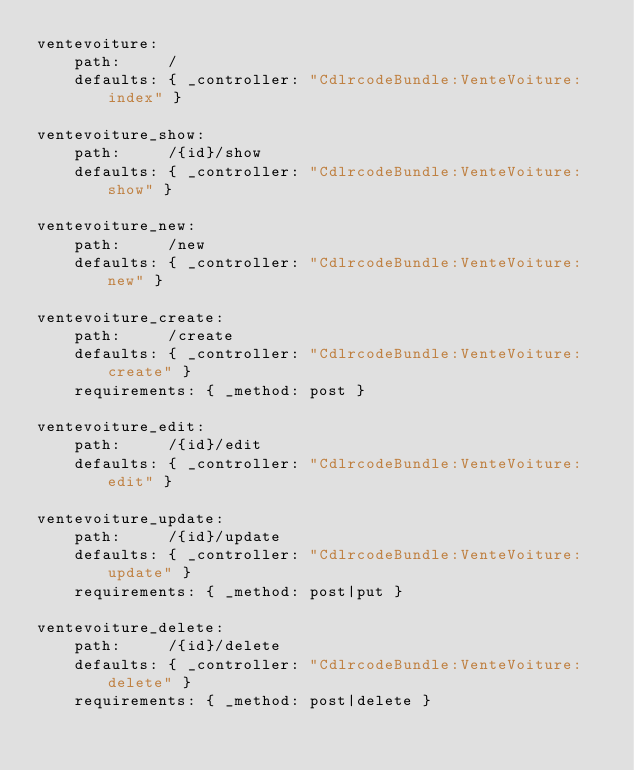<code> <loc_0><loc_0><loc_500><loc_500><_YAML_>ventevoiture:
    path:     /
    defaults: { _controller: "CdlrcodeBundle:VenteVoiture:index" }

ventevoiture_show:
    path:     /{id}/show
    defaults: { _controller: "CdlrcodeBundle:VenteVoiture:show" }

ventevoiture_new:
    path:     /new
    defaults: { _controller: "CdlrcodeBundle:VenteVoiture:new" }

ventevoiture_create:
    path:     /create
    defaults: { _controller: "CdlrcodeBundle:VenteVoiture:create" }
    requirements: { _method: post }

ventevoiture_edit:
    path:     /{id}/edit
    defaults: { _controller: "CdlrcodeBundle:VenteVoiture:edit" }

ventevoiture_update:
    path:     /{id}/update
    defaults: { _controller: "CdlrcodeBundle:VenteVoiture:update" }
    requirements: { _method: post|put }

ventevoiture_delete:
    path:     /{id}/delete
    defaults: { _controller: "CdlrcodeBundle:VenteVoiture:delete" }
    requirements: { _method: post|delete }
</code> 